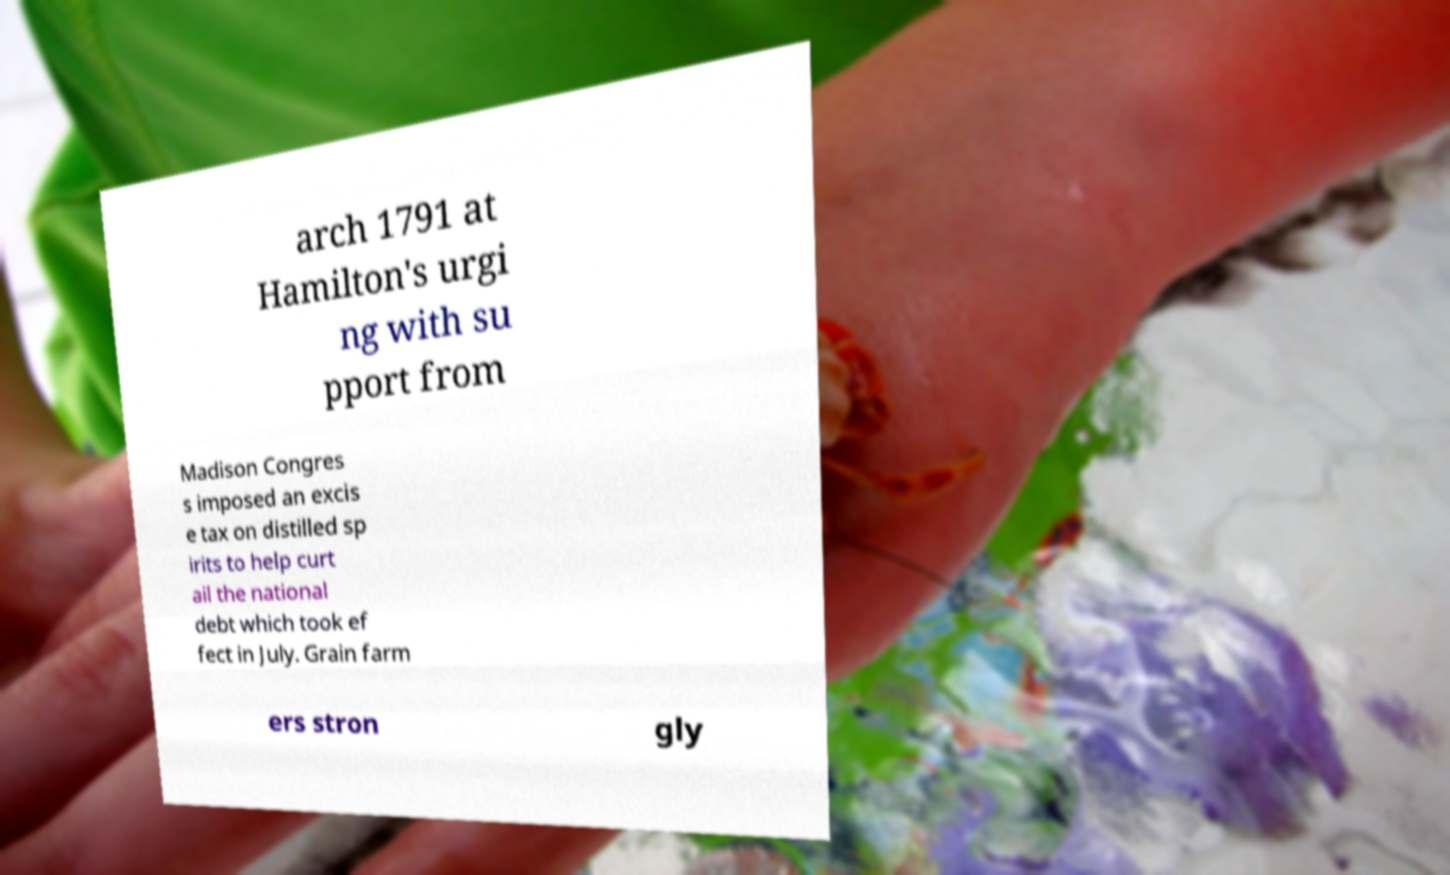Please read and relay the text visible in this image. What does it say? arch 1791 at Hamilton's urgi ng with su pport from Madison Congres s imposed an excis e tax on distilled sp irits to help curt ail the national debt which took ef fect in July. Grain farm ers stron gly 